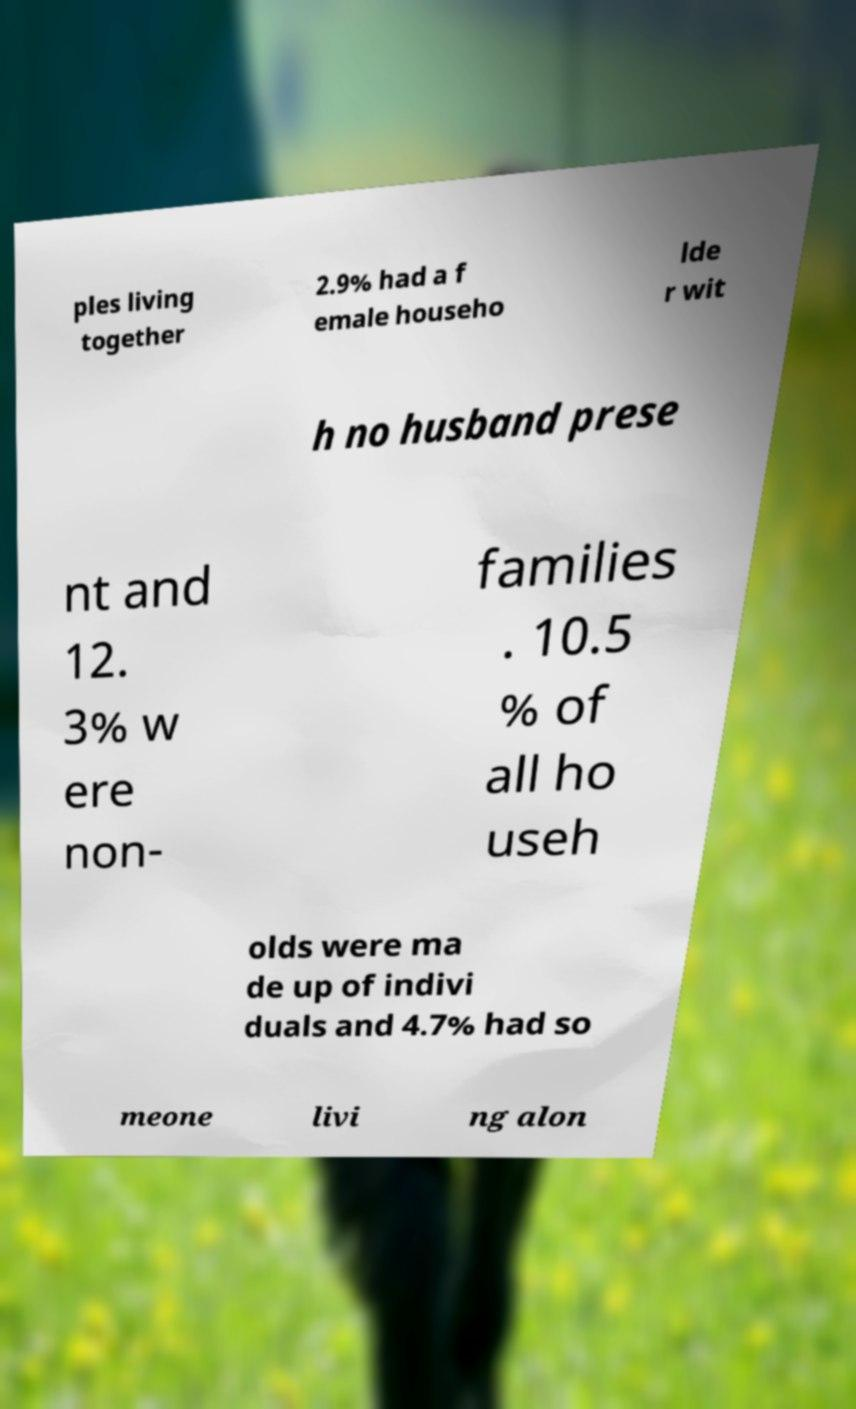Please read and relay the text visible in this image. What does it say? ples living together 2.9% had a f emale househo lde r wit h no husband prese nt and 12. 3% w ere non- families . 10.5 % of all ho useh olds were ma de up of indivi duals and 4.7% had so meone livi ng alon 